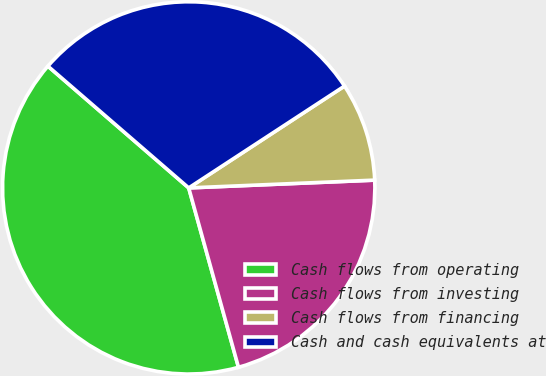Convert chart to OTSL. <chart><loc_0><loc_0><loc_500><loc_500><pie_chart><fcel>Cash flows from operating<fcel>Cash flows from investing<fcel>Cash flows from financing<fcel>Cash and cash equivalents at<nl><fcel>40.66%<fcel>21.36%<fcel>8.55%<fcel>29.44%<nl></chart> 